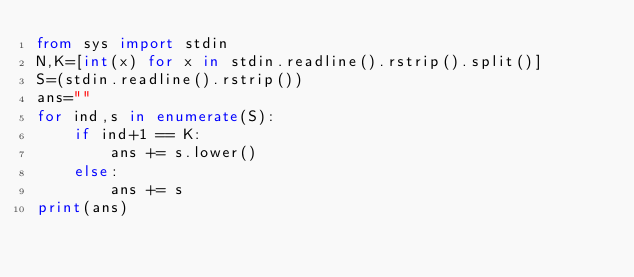Convert code to text. <code><loc_0><loc_0><loc_500><loc_500><_Python_>from sys import stdin
N,K=[int(x) for x in stdin.readline().rstrip().split()]
S=(stdin.readline().rstrip())
ans=""
for ind,s in enumerate(S):
    if ind+1 == K:
        ans += s.lower()
    else:
        ans += s
print(ans)</code> 